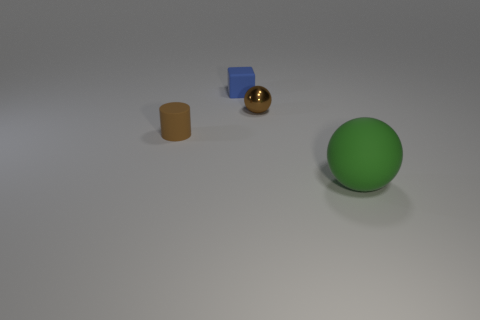Are there any other things that have the same material as the tiny sphere?
Provide a short and direct response. No. What number of large matte balls are the same color as the metallic object?
Offer a terse response. 0. What is the material of the small ball that is the same color as the small matte cylinder?
Offer a terse response. Metal. Is the number of large green objects right of the rubber cylinder greater than the number of big yellow blocks?
Keep it short and to the point. Yes. Do the small brown rubber thing and the large green thing have the same shape?
Provide a succinct answer. No. How many other big green objects have the same material as the large thing?
Keep it short and to the point. 0. What size is the green thing that is the same shape as the tiny brown metallic thing?
Make the answer very short. Large. Is the brown cylinder the same size as the green rubber object?
Keep it short and to the point. No. What shape is the object behind the tiny brown object right of the small brown object in front of the metal object?
Provide a succinct answer. Cube. What is the color of the other object that is the same shape as the large green object?
Your answer should be very brief. Brown. 